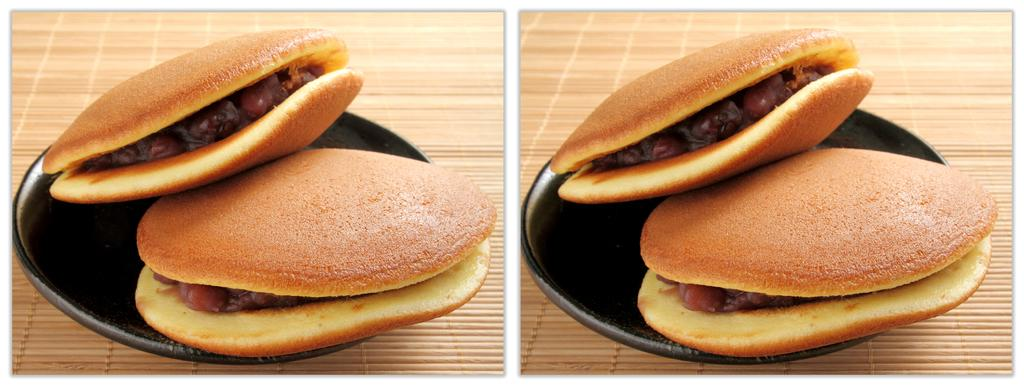What type of food is on the platter in the image? There are confections on a black platter in the image. What is the color of the platter? The platter is black. What is the surface beneath the platter made of? The black platter is on a wooden surface. Where is the scene of the confections and platter located in the image? The scene is in the foreground of the image. What decision does the book on the wooden surface make in the image? There is no book present in the image, so no decision can be made by a book. 